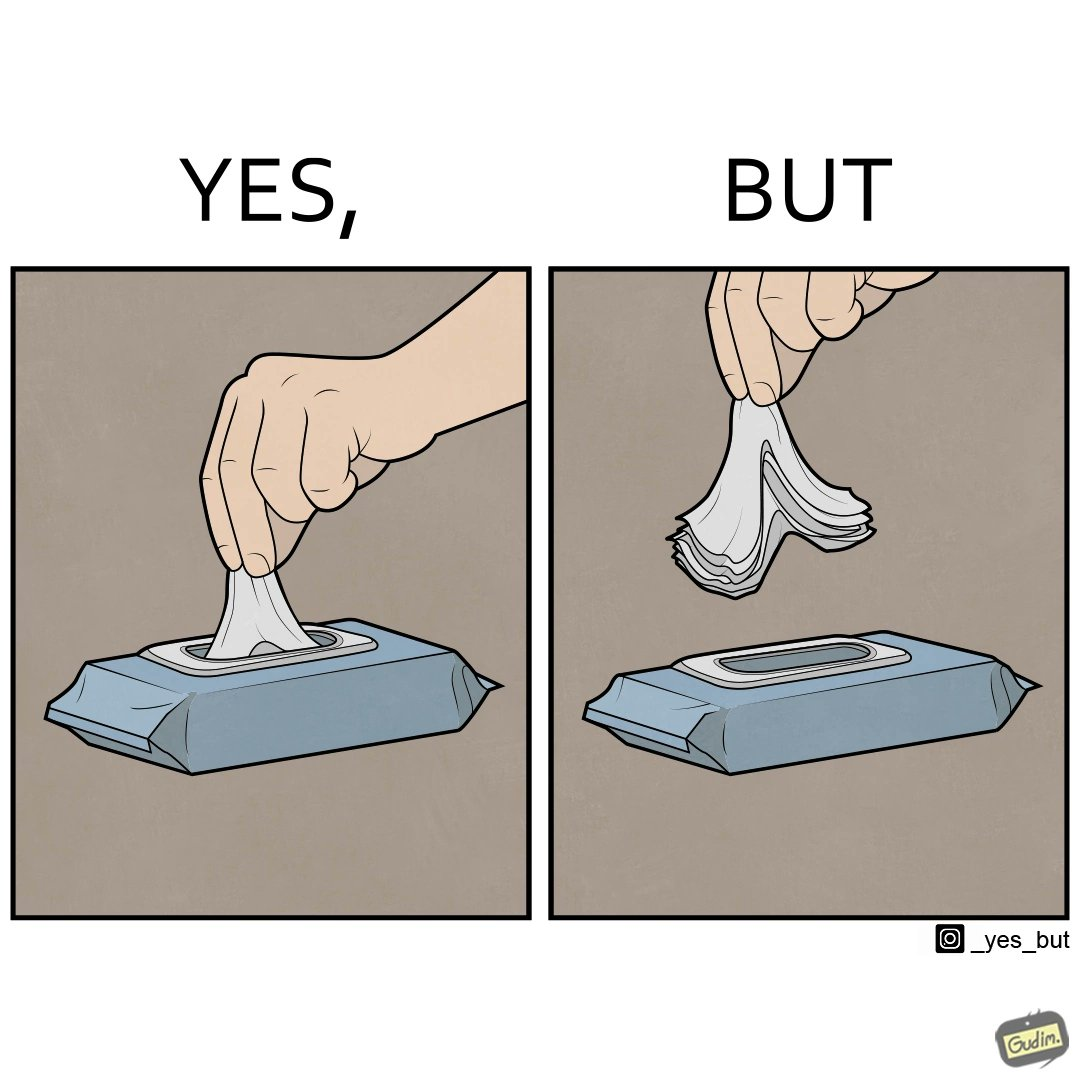Is this image satirical or non-satirical? Yes, this image is satirical. 